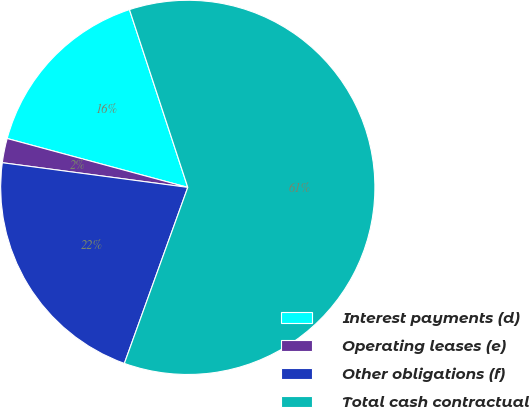Convert chart. <chart><loc_0><loc_0><loc_500><loc_500><pie_chart><fcel>Interest payments (d)<fcel>Operating leases (e)<fcel>Other obligations (f)<fcel>Total cash contractual<nl><fcel>15.75%<fcel>2.1%<fcel>21.6%<fcel>60.55%<nl></chart> 